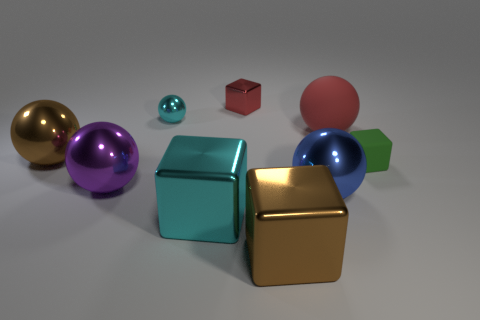Subtract all brown balls. How many balls are left? 4 Subtract all small shiny balls. How many balls are left? 4 Subtract 1 blocks. How many blocks are left? 3 Add 1 small brown shiny cylinders. How many objects exist? 10 Subtract all blue blocks. Subtract all brown spheres. How many blocks are left? 4 Subtract all cubes. How many objects are left? 5 Add 4 big cyan shiny blocks. How many big cyan shiny blocks exist? 5 Subtract 0 red cylinders. How many objects are left? 9 Subtract all small cyan objects. Subtract all tiny red objects. How many objects are left? 7 Add 5 tiny red shiny things. How many tiny red shiny things are left? 6 